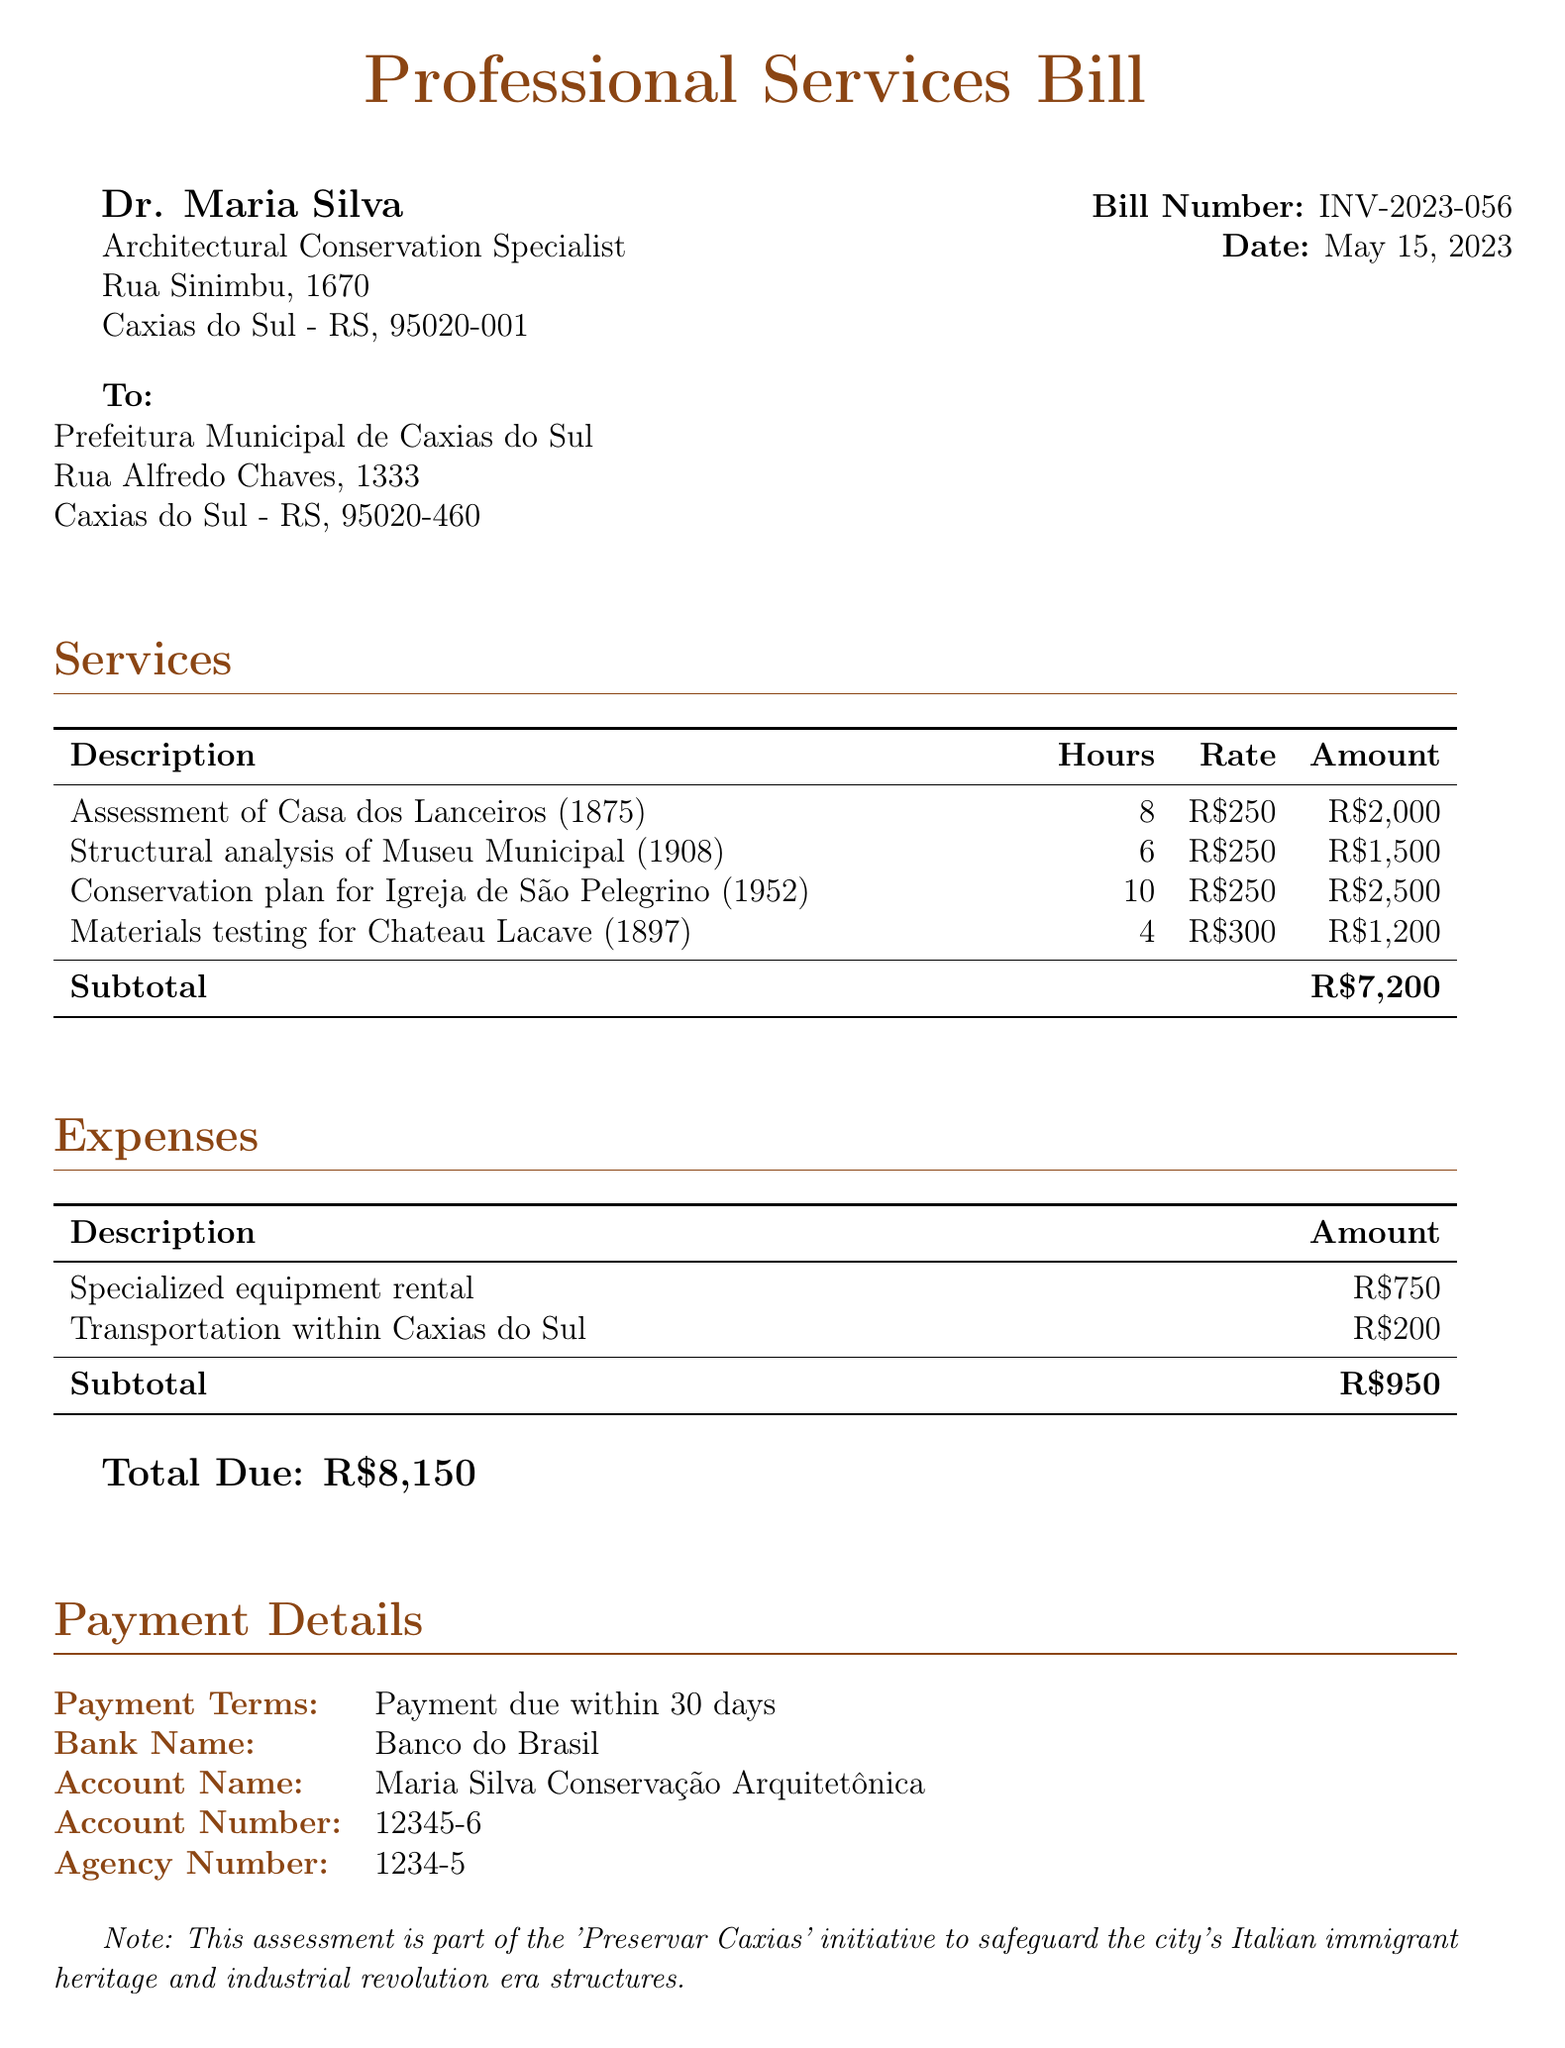What is the bill number? The bill number is specified in the document under the header, identifying the particular bill.
Answer: INV-2023-056 Who is the conservation expert? The expert's name is given in the document, detailing who provided the professional services.
Answer: Dr. Maria Silva What is the total due amount? The total due amount is listed at the end of the payment details, indicating how much needs to be paid.
Answer: R$8,150 How many hours were spent on the assessment of Casa dos Lanceiros? The document provides a specific number of hours allocated for each service, including this assessment.
Answer: 8 What is the rate for materials testing? The rate is mentioned in the services section, stating how much is charged per hour for this specific service.
Answer: R$300 What is the subtotal for expenses? This subtotal is calculated from all expenses listed in that section, providing insight into overall expenditure beyond services.
Answer: R$950 What initiative is the assessment part of? The document notes an initiative aimed at preserving heritage, indicating its purpose and significance.
Answer: Preservar Caxias What is the payment term? The payment term specifies when payment is expected to be made after the bill is issued, indicating the timeframe for settlement.
Answer: Payment due within 30 days How many hours were allocated for the conservation plan for Igreja de São Pelegrino? The number of hours dedicated to the conservation plan is given explicitly in the services table.
Answer: 10 